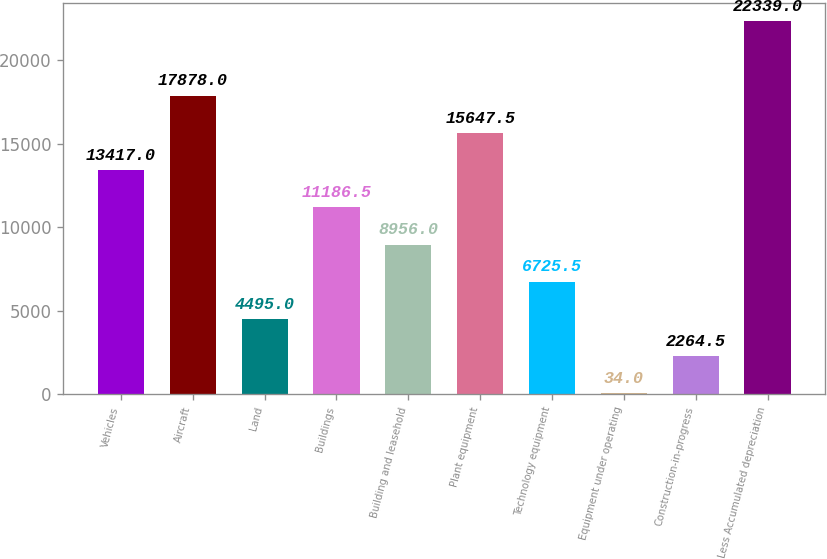<chart> <loc_0><loc_0><loc_500><loc_500><bar_chart><fcel>Vehicles<fcel>Aircraft<fcel>Land<fcel>Buildings<fcel>Building and leasehold<fcel>Plant equipment<fcel>Technology equipment<fcel>Equipment under operating<fcel>Construction-in-progress<fcel>Less Accumulated depreciation<nl><fcel>13417<fcel>17878<fcel>4495<fcel>11186.5<fcel>8956<fcel>15647.5<fcel>6725.5<fcel>34<fcel>2264.5<fcel>22339<nl></chart> 